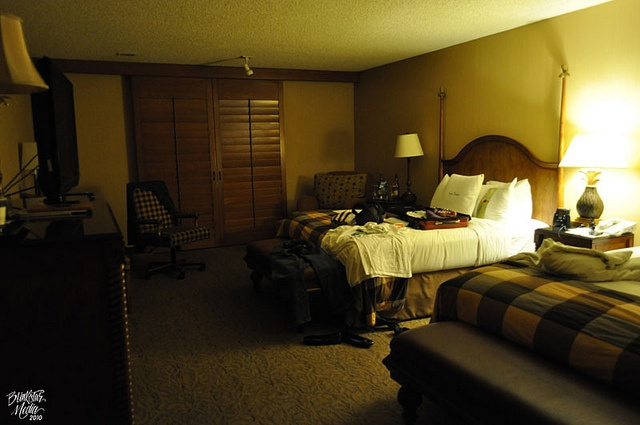Describe the objects in this image and their specific colors. I can see bed in black and olive tones, bed in black, maroon, ivory, and olive tones, tv in black tones, chair in black, maroon, and olive tones, and chair in black and olive tones in this image. 